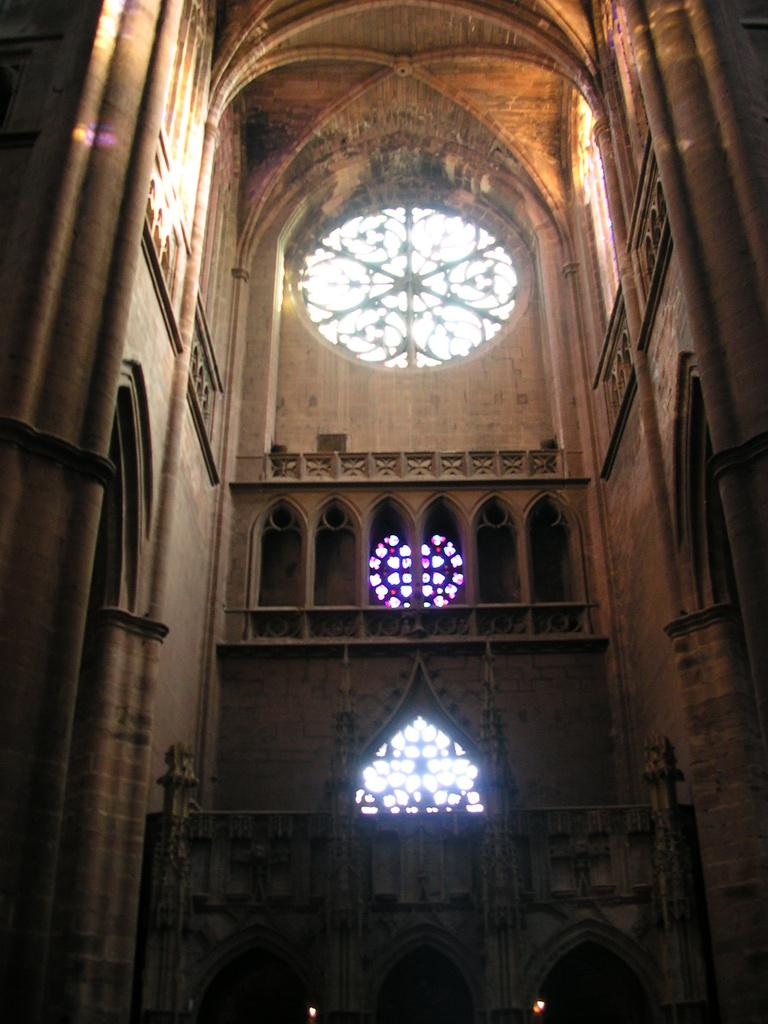What type of view does the image provide? The image shows an interior view of a building. Can you describe any specific features of the interior? Unfortunately, the provided facts do not mention any specific features of the interior. Is there any natural light coming into the building in the image? Yes, there is a window visible at the top of the image, which suggests that natural light is entering the building. What type of farming equipment can be seen in the image? There is no farming equipment present in the image, as it shows an interior view of a building. What type of furniture is visible in the image? The provided facts do not mention any furniture in the image. 